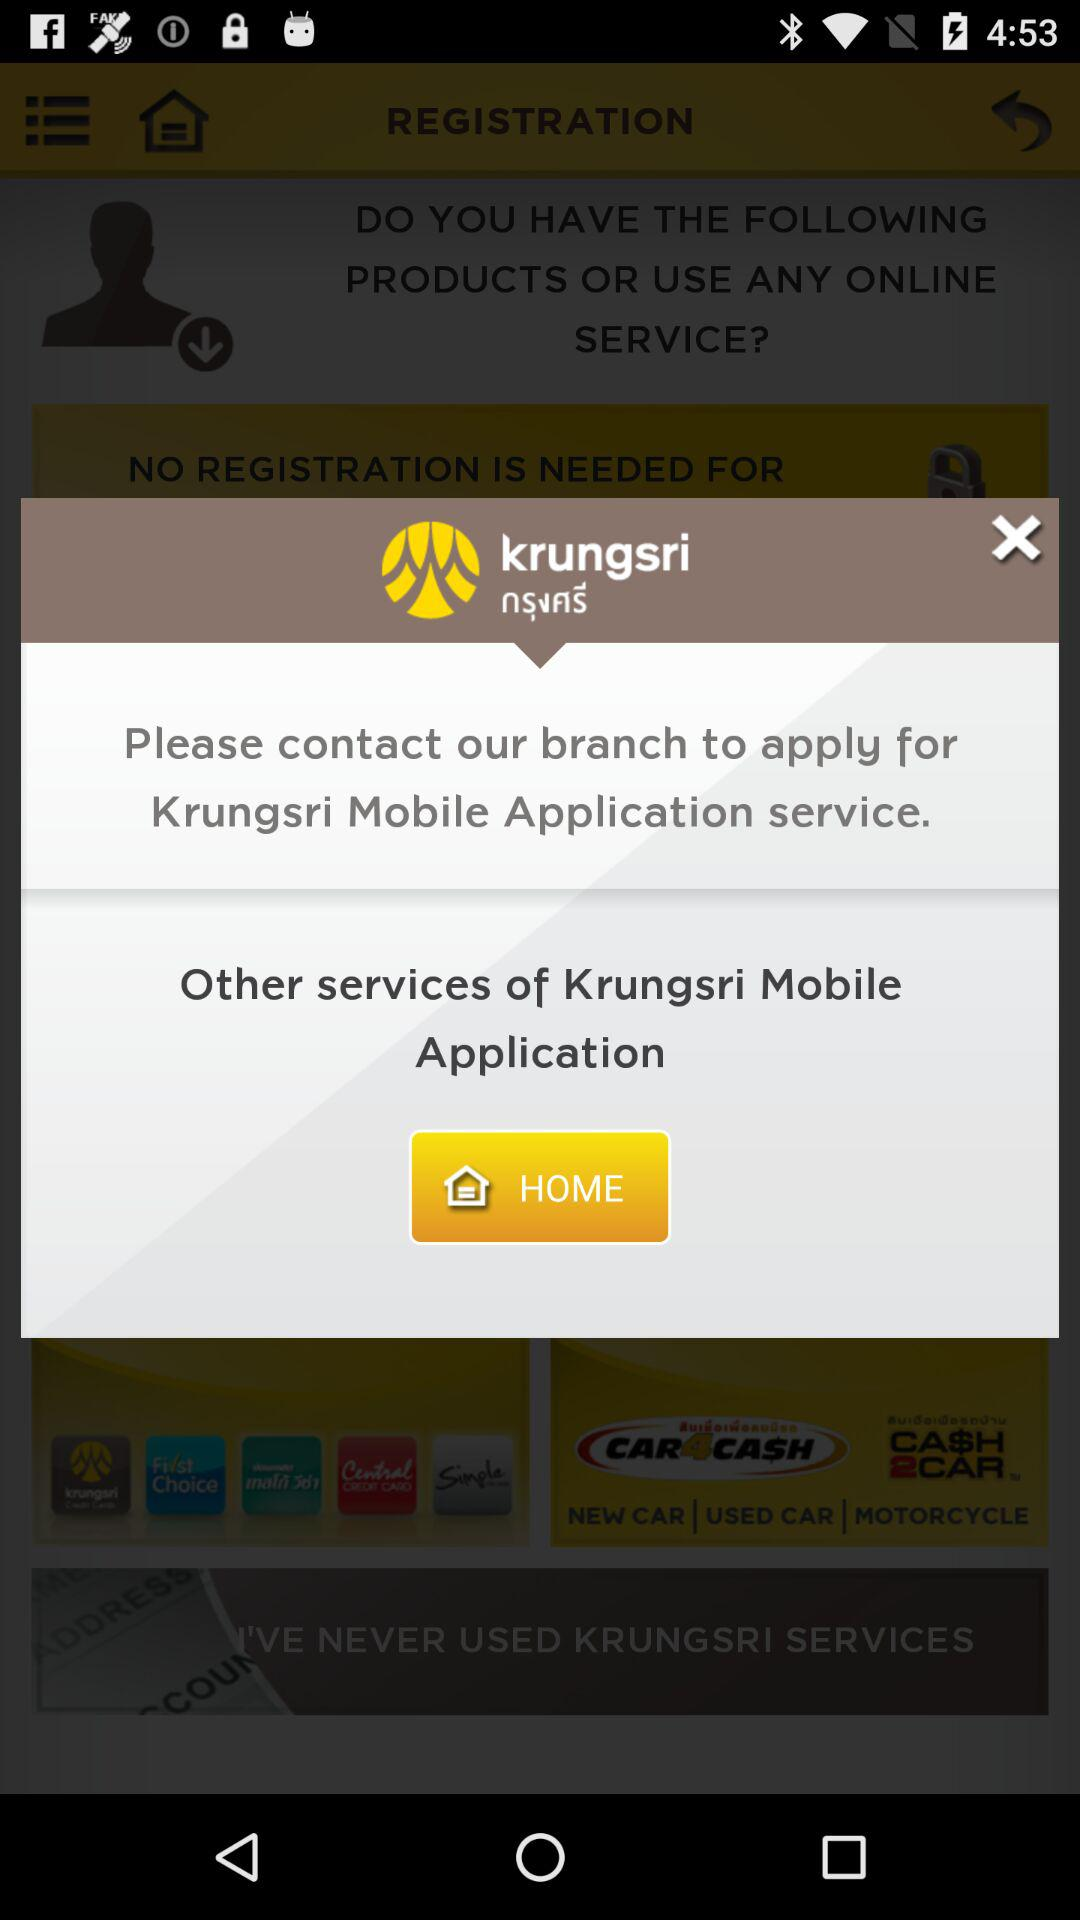What is the app name? The app name is "Krungsri Mobile Application". 